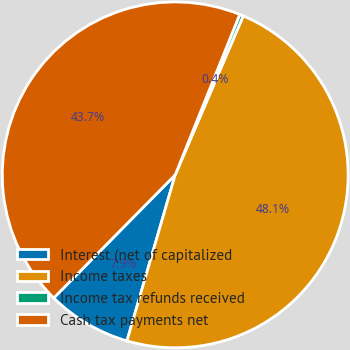<chart> <loc_0><loc_0><loc_500><loc_500><pie_chart><fcel>Interest (net of capitalized<fcel>Income taxes<fcel>Income tax refunds received<fcel>Cash tax payments net<nl><fcel>7.89%<fcel>48.06%<fcel>0.35%<fcel>43.69%<nl></chart> 